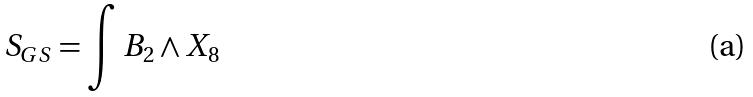<formula> <loc_0><loc_0><loc_500><loc_500>S _ { G S } = \int B _ { 2 } \wedge X _ { 8 }</formula> 